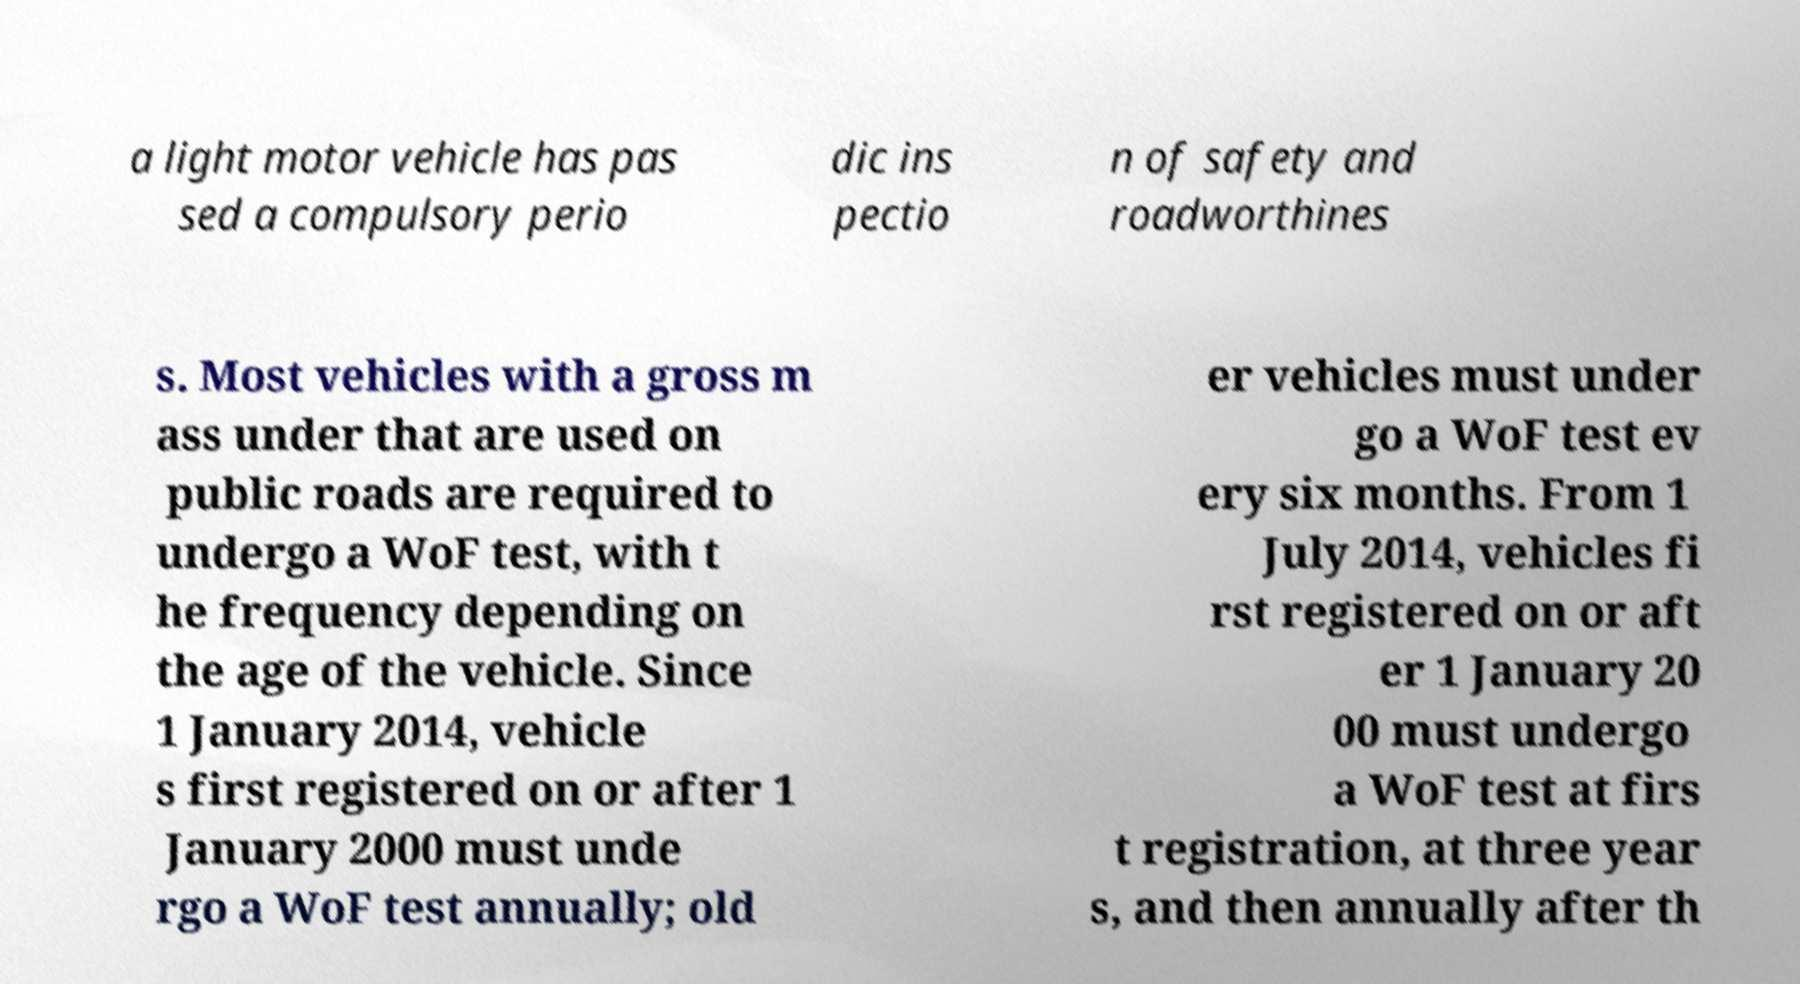There's text embedded in this image that I need extracted. Can you transcribe it verbatim? a light motor vehicle has pas sed a compulsory perio dic ins pectio n of safety and roadworthines s. Most vehicles with a gross m ass under that are used on public roads are required to undergo a WoF test, with t he frequency depending on the age of the vehicle. Since 1 January 2014, vehicle s first registered on or after 1 January 2000 must unde rgo a WoF test annually; old er vehicles must under go a WoF test ev ery six months. From 1 July 2014, vehicles fi rst registered on or aft er 1 January 20 00 must undergo a WoF test at firs t registration, at three year s, and then annually after th 